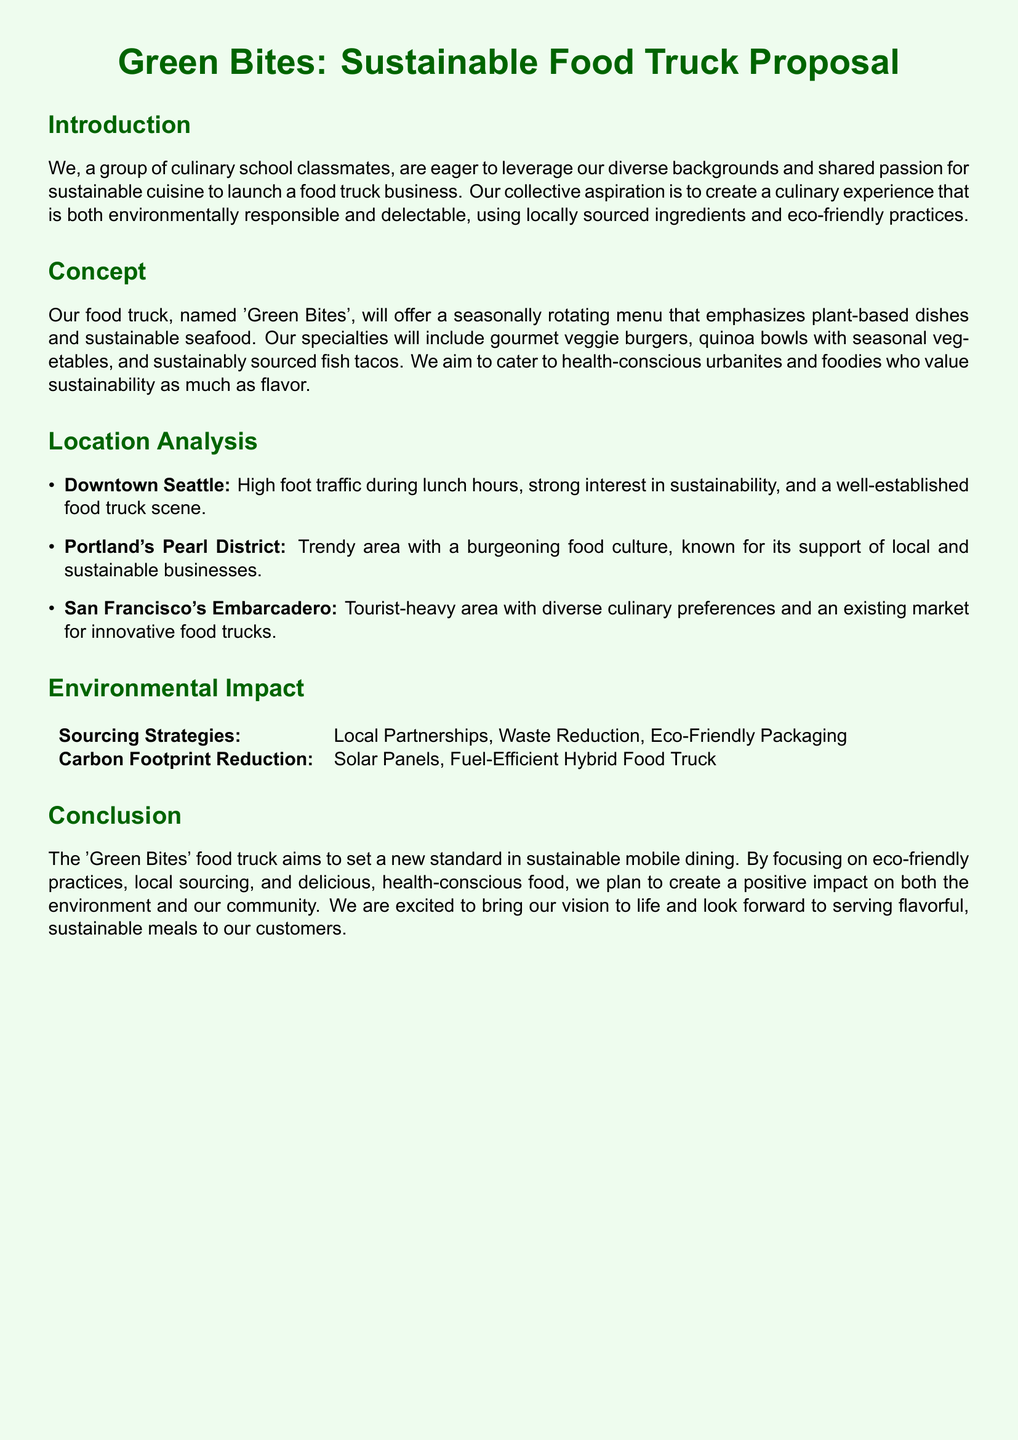What is the name of the food truck? The food truck is named in the concept section of the document.
Answer: Green Bites What types of dishes will 'Green Bites' offer? The concept section mentions specific dish types that will be served.
Answer: Plant-based dishes and sustainable seafood Which city has a strong interest in sustainability? This information is found in the location analysis section.
Answer: Seattle What are the sourcing strategies listed in the environmental impact section? The table in the environmental impact section outlines specific strategies.
Answer: Local Partnerships, Waste Reduction, Eco-Friendly Packaging How many locations are analyzed in the proposal? The location analysis section lists specific areas considered for the food truck.
Answer: Three What is one way 'Green Bites' plans to reduce its carbon footprint? The environmental impact section provides specific methods for reduction.
Answer: Solar Panels Which area is known for its support of local businesses? The location analysis section indicates an area with a specific characteristic.
Answer: Portland's Pearl District What will be the focus of 'Green Bites'? The introduction outlines the main objective of the food truck business.
Answer: Sustainable mobile dining What type of customers does 'Green Bites' aim to cater to? The concept section describes the target customer base for the food truck.
Answer: Health-conscious urbanites and foodies 